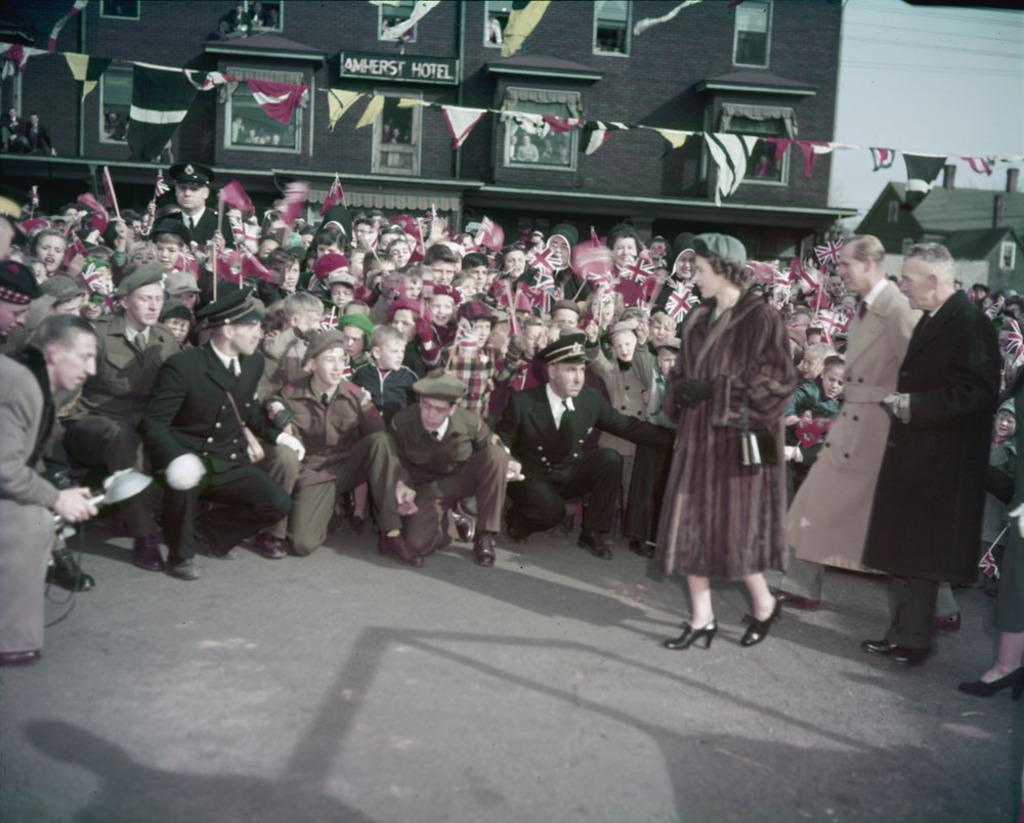What is the main subject of the image? The main subject of the image is multiple persons in the middle of the image. What structure can be seen at the top of the image? There is a building at the top of the image. What activity can be observed on the right side of the image? There are people walking on the right side of the image. What type of snakes can be seen slithering on the ground in the image? There are no snakes present in the image. What is the group of people having for breakfast in the image? There is no mention of breakfast or food in the image. 